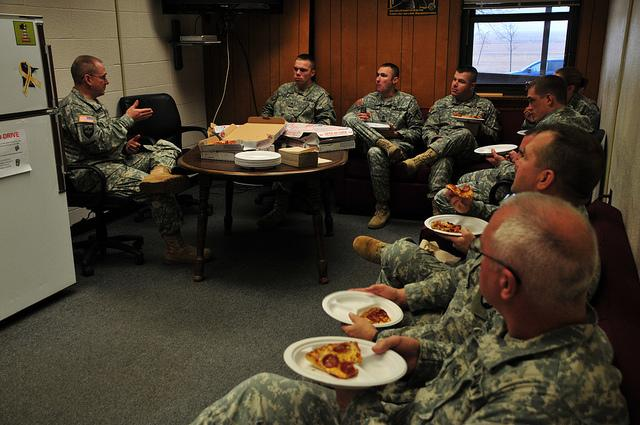What are they doing? eating pizza 